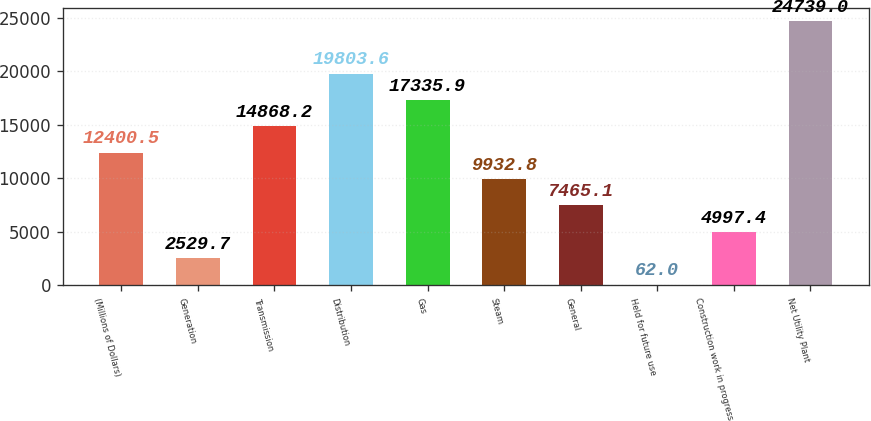<chart> <loc_0><loc_0><loc_500><loc_500><bar_chart><fcel>(Millions of Dollars)<fcel>Generation<fcel>Transmission<fcel>Distribution<fcel>Gas<fcel>Steam<fcel>General<fcel>Held for future use<fcel>Construction work in progress<fcel>Net Utility Plant<nl><fcel>12400.5<fcel>2529.7<fcel>14868.2<fcel>19803.6<fcel>17335.9<fcel>9932.8<fcel>7465.1<fcel>62<fcel>4997.4<fcel>24739<nl></chart> 